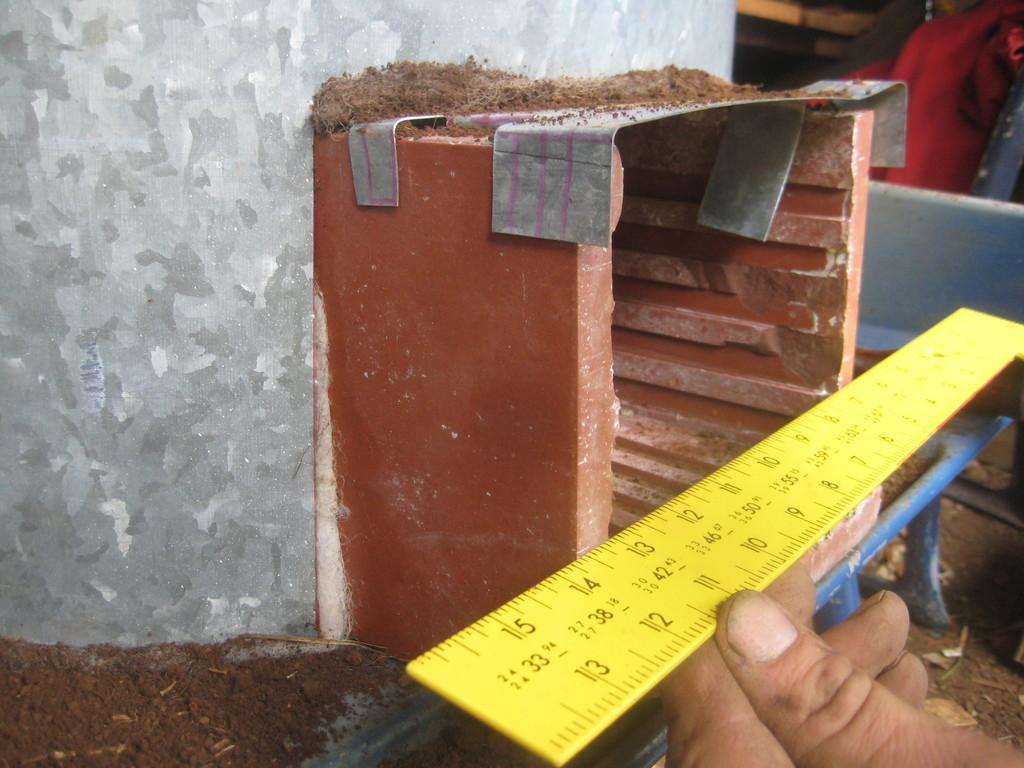<image>
Offer a succinct explanation of the picture presented. A yellow ruler goes up to 15 inches on one side. 